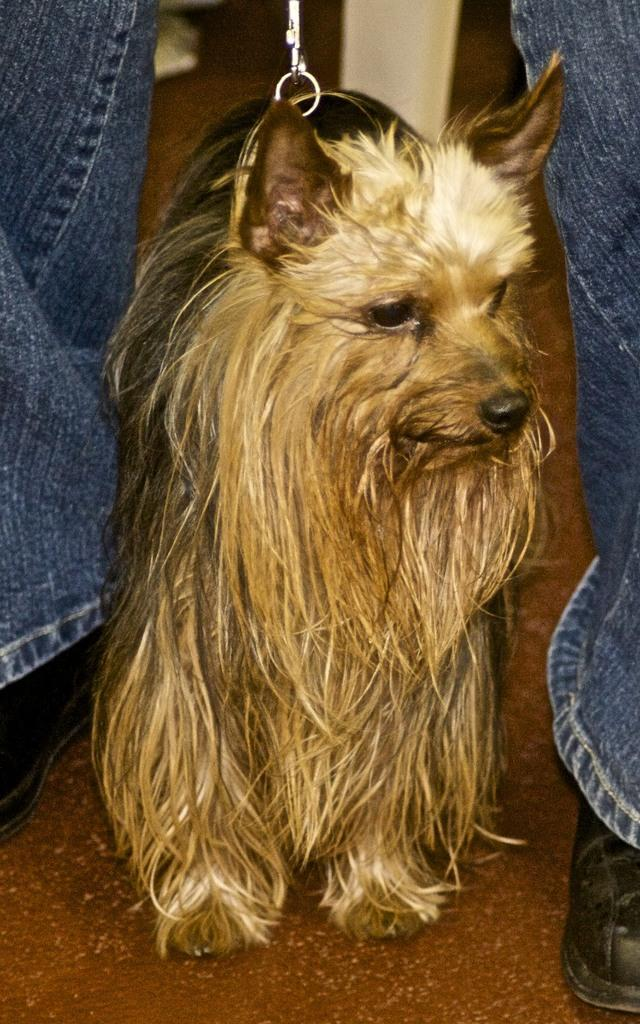What is the main subject of the image? There is a person standing in the image. What other living creature is present in the image? There is a dog standing in the image. Can you describe the object at the back of the image? Unfortunately, the facts provided do not give any details about the object at the back of the image. What type of surface is visible at the bottom of the image? There is a floor visible at the bottom of the image. What type of rifle is the person holding in the image? There is no rifle present in the image; the person is simply standing. What is the dog's desire in the image? There is no information provided about the dog's desires in the image. 